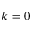Convert formula to latex. <formula><loc_0><loc_0><loc_500><loc_500>k = 0</formula> 